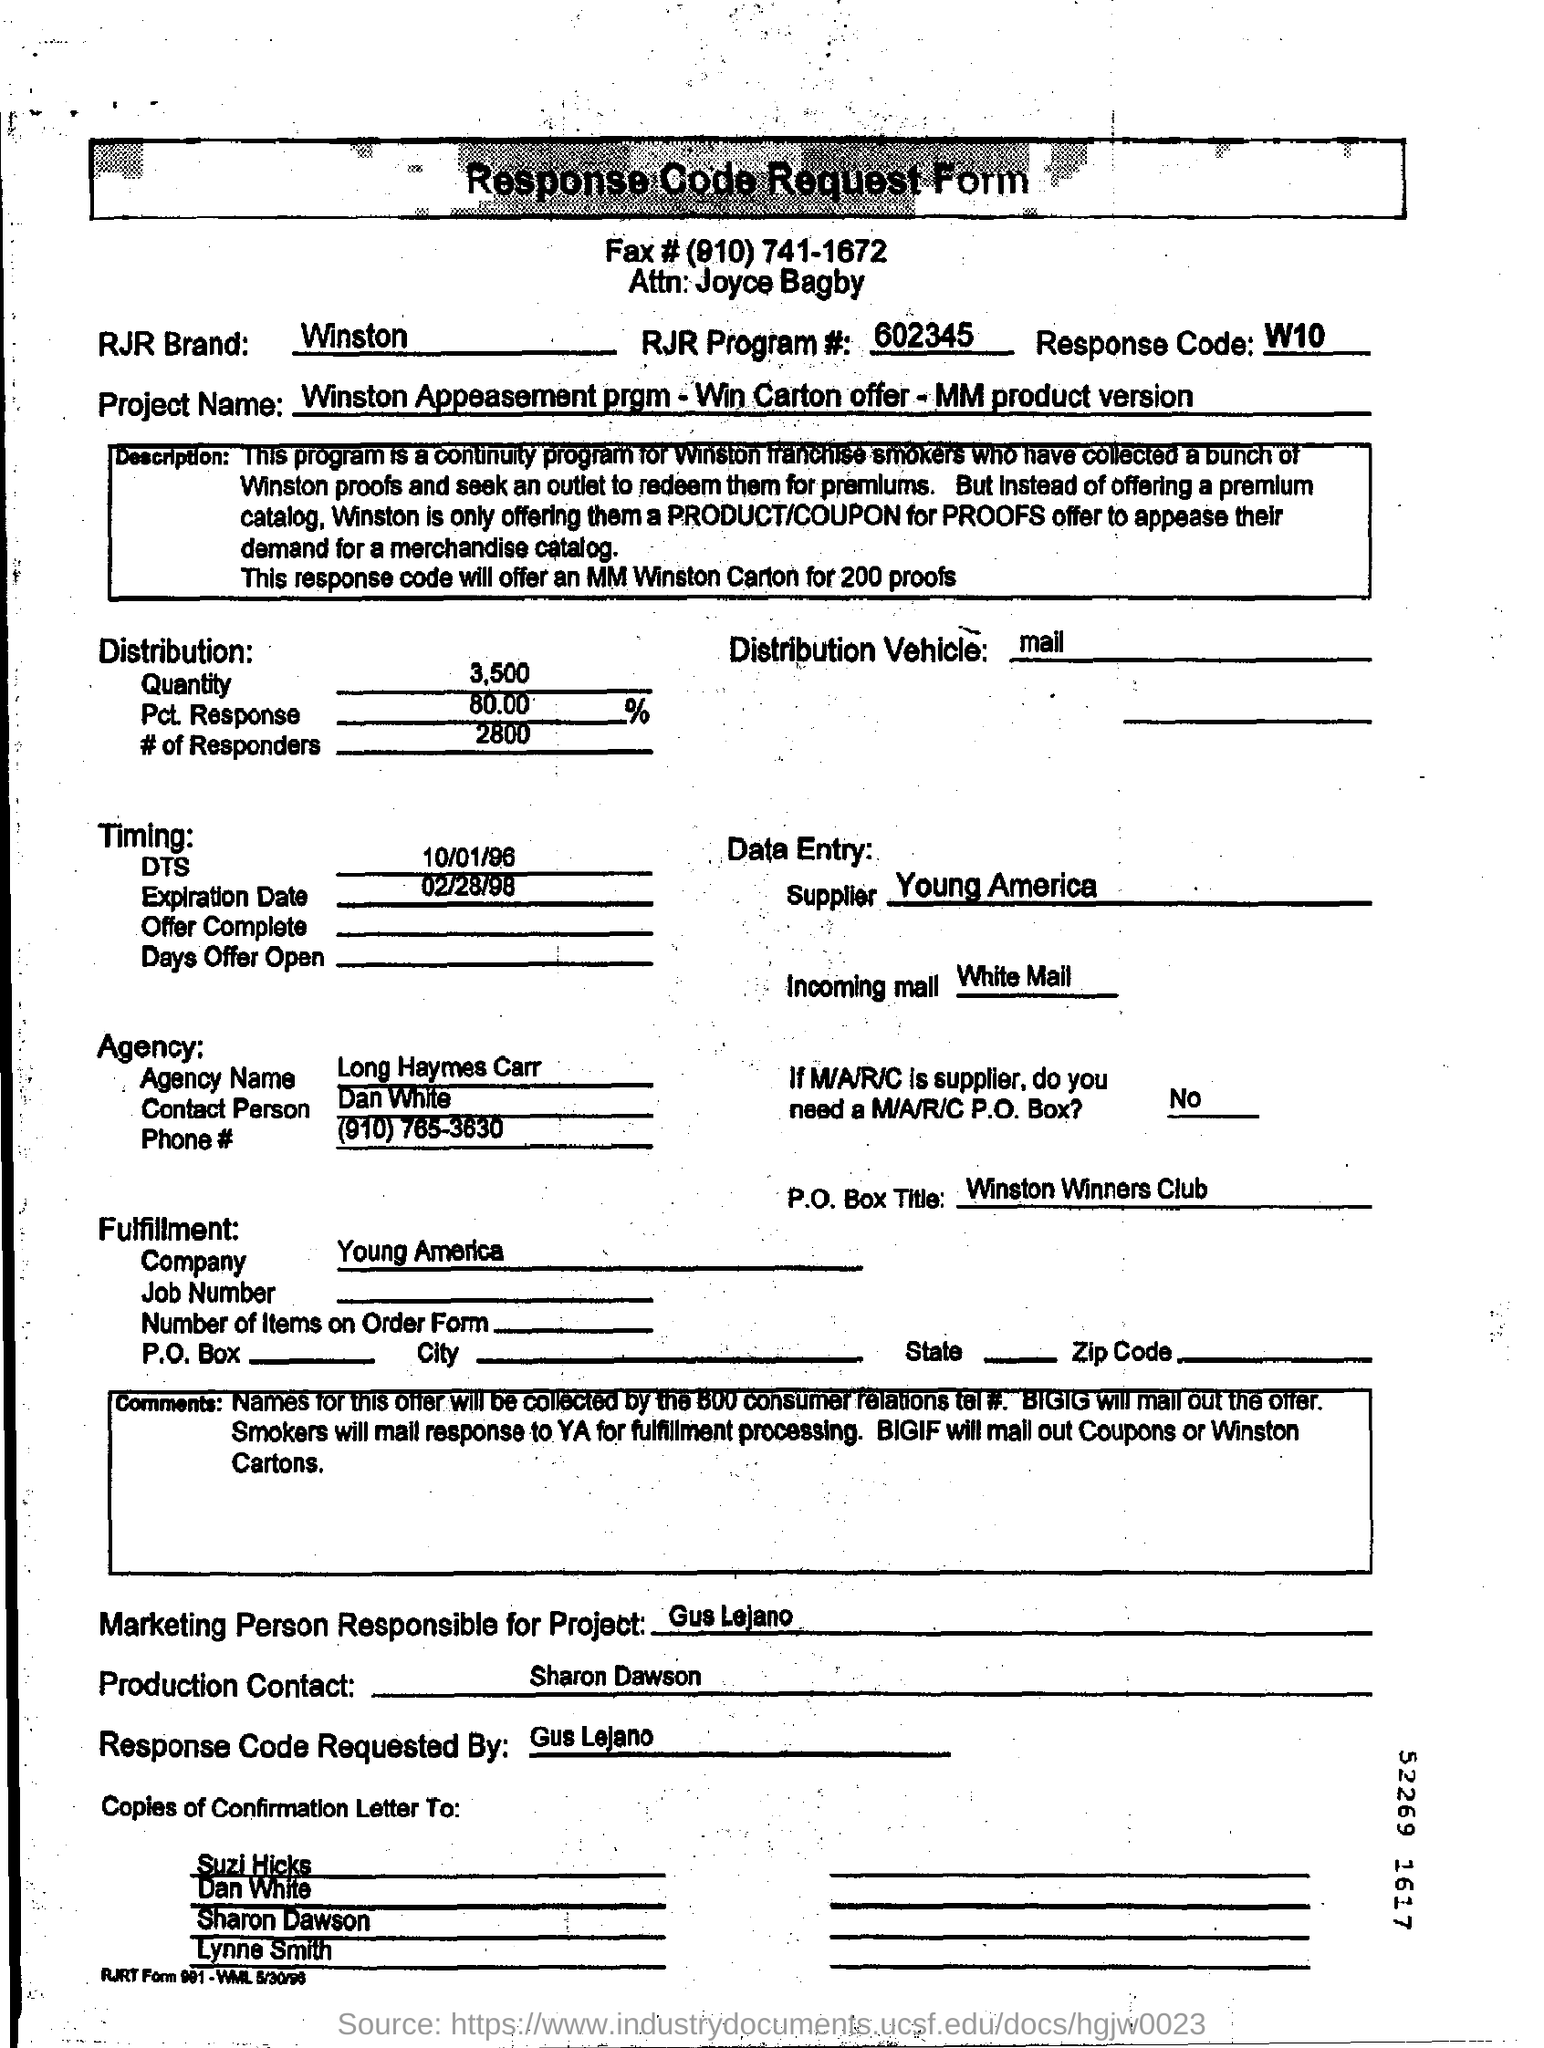What is the Title of the document ?
Give a very brief answer. Response code request form. What is the Fax Number ?
Provide a short and direct response. (910) 741-1672. What is the Response Code ?
Provide a succinct answer. W10. What is the RJR Program Number ?
Provide a succinct answer. 602345. Who is the Supplier ?
Provide a succinct answer. Young America. What is the Agency Name ?
Offer a very short reply. Long Haymes Carr. What is written in the P.O.Box Title Field ?
Make the answer very short. Winston Winners Club. What is the Expiration Date ?
Give a very brief answer. 02/28/98. What is written in the Production Contact Field ?
Provide a short and direct response. Sharon Dawson. What date mentioned in the DTS Field ?
Offer a terse response. 10/01/96. 